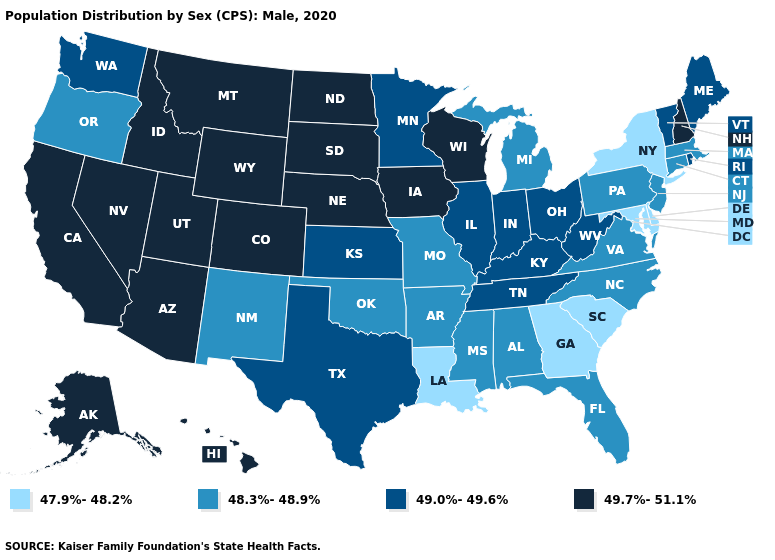What is the value of Ohio?
Answer briefly. 49.0%-49.6%. Among the states that border Vermont , does New York have the highest value?
Concise answer only. No. Does Montana have the highest value in the USA?
Give a very brief answer. Yes. What is the value of Arkansas?
Write a very short answer. 48.3%-48.9%. Name the states that have a value in the range 48.3%-48.9%?
Short answer required. Alabama, Arkansas, Connecticut, Florida, Massachusetts, Michigan, Mississippi, Missouri, New Jersey, New Mexico, North Carolina, Oklahoma, Oregon, Pennsylvania, Virginia. What is the highest value in states that border Michigan?
Short answer required. 49.7%-51.1%. Name the states that have a value in the range 48.3%-48.9%?
Write a very short answer. Alabama, Arkansas, Connecticut, Florida, Massachusetts, Michigan, Mississippi, Missouri, New Jersey, New Mexico, North Carolina, Oklahoma, Oregon, Pennsylvania, Virginia. Name the states that have a value in the range 49.0%-49.6%?
Be succinct. Illinois, Indiana, Kansas, Kentucky, Maine, Minnesota, Ohio, Rhode Island, Tennessee, Texas, Vermont, Washington, West Virginia. What is the value of Utah?
Write a very short answer. 49.7%-51.1%. What is the value of North Carolina?
Answer briefly. 48.3%-48.9%. Does Michigan have a higher value than Georgia?
Be succinct. Yes. What is the lowest value in the West?
Short answer required. 48.3%-48.9%. Does Alaska have a higher value than Utah?
Keep it brief. No. Name the states that have a value in the range 47.9%-48.2%?
Concise answer only. Delaware, Georgia, Louisiana, Maryland, New York, South Carolina. Among the states that border New Mexico , which have the lowest value?
Be succinct. Oklahoma. 